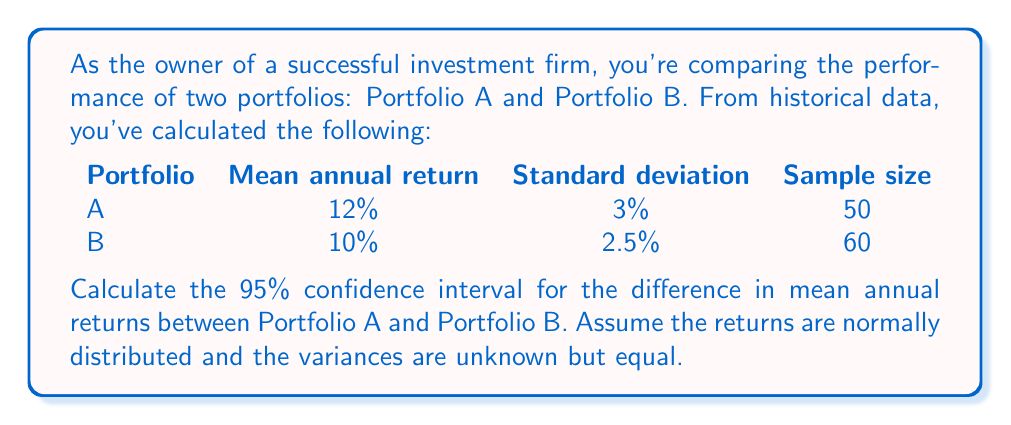Show me your answer to this math problem. To calculate the confidence interval for the difference in mean annual returns, we'll follow these steps:

1) First, we need to calculate the pooled standard error:

   $$SE_{pooled} = \sqrt{\frac{s_1^2}{n_1} + \frac{s_2^2}{n_2}}$$

   Where $s_1$ and $s_2$ are the standard deviations, and $n_1$ and $n_2$ are the sample sizes.

   $$SE_{pooled} = \sqrt{\frac{3^2}{50} + \frac{2.5^2}{60}} = \sqrt{0.18 + 0.104} = \sqrt{0.284} = 0.533$$

2) The difference in means is:

   $$\bar{x_1} - \bar{x_2} = 12\% - 10\% = 2\%$$

3) For a 95% confidence interval, we use a t-value with degrees of freedom:

   $$df = n_1 + n_2 - 2 = 50 + 60 - 2 = 108$$

   The t-value for a 95% CI with 108 df is approximately 1.98 (from t-table).

4) The confidence interval is calculated as:

   $$(\bar{x_1} - \bar{x_2}) \pm t_{0.025, 108} \times SE_{pooled}$$

   $$2\% \pm 1.98 \times 0.533$$

   $$2\% \pm 1.055\%$$

5) Therefore, the 95% confidence interval is:

   $$(0.945\%, 3.055\%)$$
Answer: (0.945%, 3.055%) 